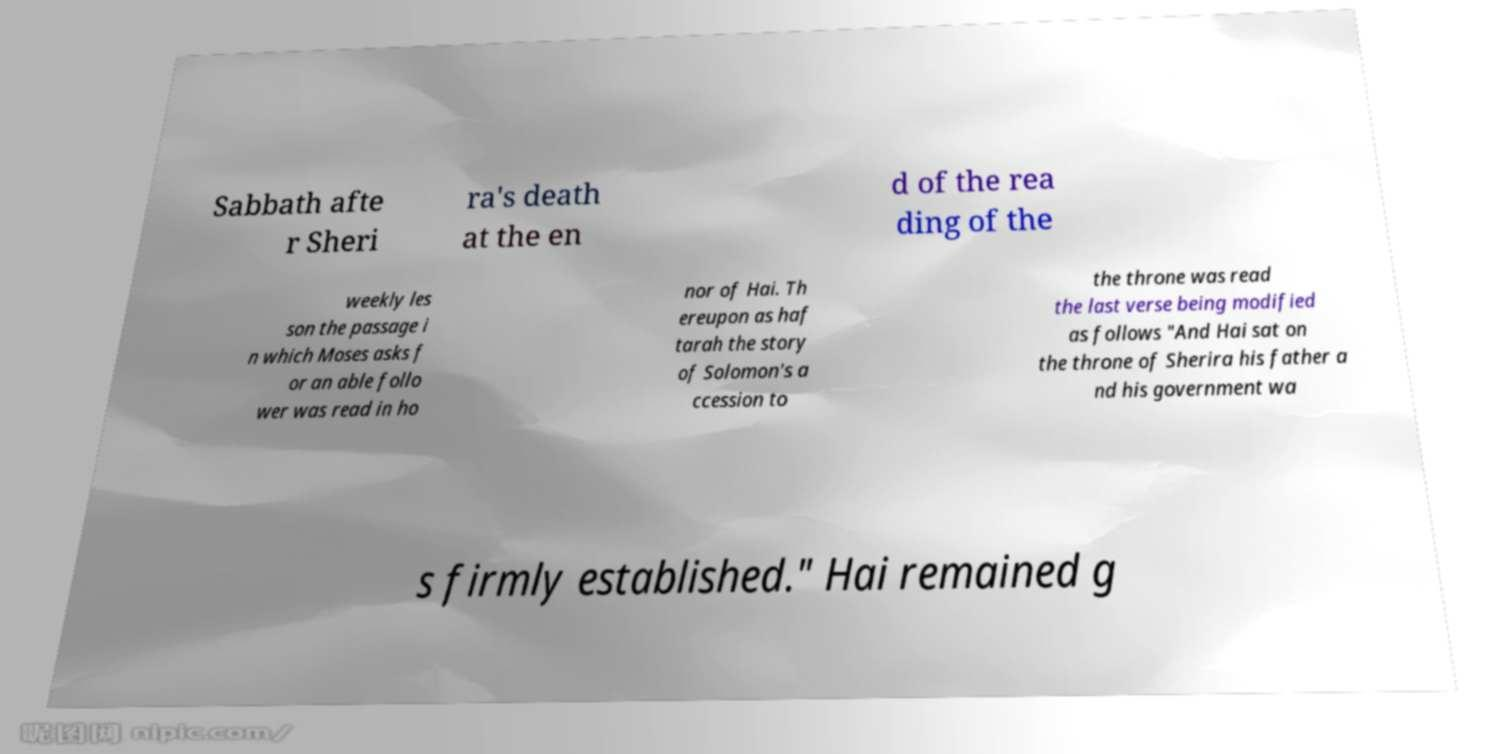I need the written content from this picture converted into text. Can you do that? Sabbath afte r Sheri ra's death at the en d of the rea ding of the weekly les son the passage i n which Moses asks f or an able follo wer was read in ho nor of Hai. Th ereupon as haf tarah the story of Solomon's a ccession to the throne was read the last verse being modified as follows "And Hai sat on the throne of Sherira his father a nd his government wa s firmly established." Hai remained g 